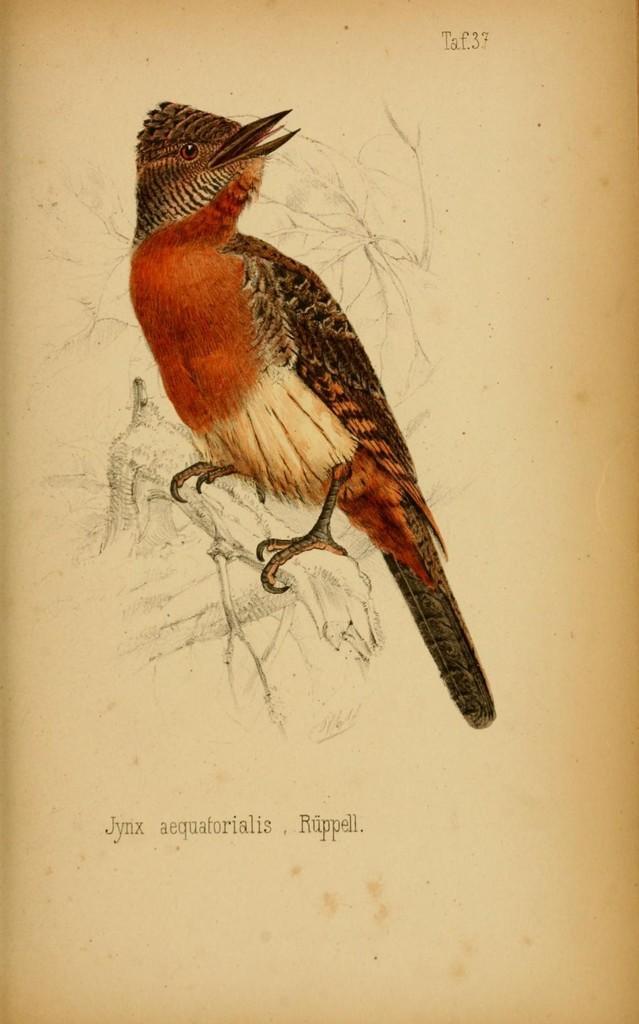Describe this image in one or two sentences. In this picture we can see art on the paper. 